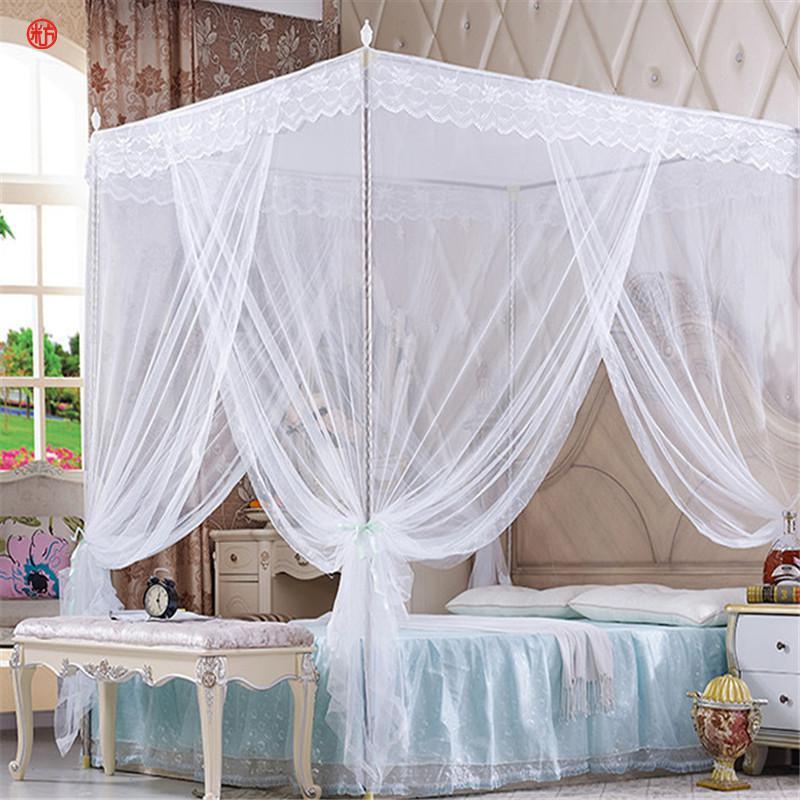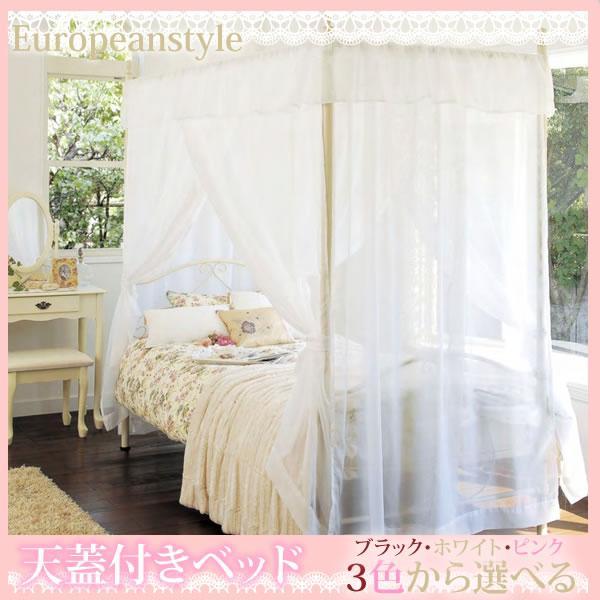The first image is the image on the left, the second image is the image on the right. Examine the images to the left and right. Is the description "The left and right image contains the same number of square open lace canopies." accurate? Answer yes or no. Yes. The first image is the image on the left, the second image is the image on the right. Examine the images to the left and right. Is the description "One image shows a sheer pinkish canopy with a ruffled border around the top, on a four-post bed." accurate? Answer yes or no. No. 